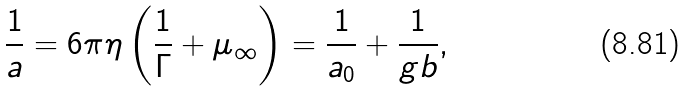<formula> <loc_0><loc_0><loc_500><loc_500>\frac { 1 } { a } = 6 \pi \eta \left ( \frac { 1 } { \Gamma } + \mu _ { \infty } \right ) = \frac { 1 } { a _ { 0 } } + \frac { 1 } { g b } ,</formula> 